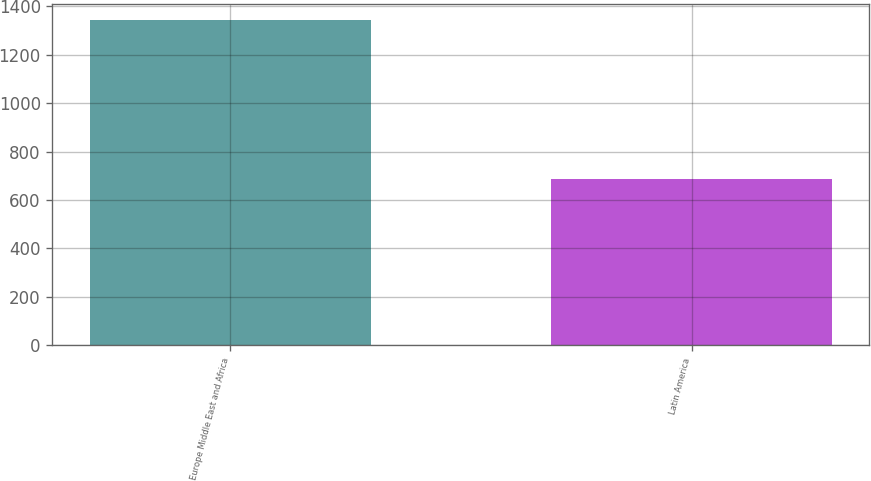Convert chart. <chart><loc_0><loc_0><loc_500><loc_500><bar_chart><fcel>Europe Middle East and Africa<fcel>Latin America<nl><fcel>1344<fcel>687<nl></chart> 